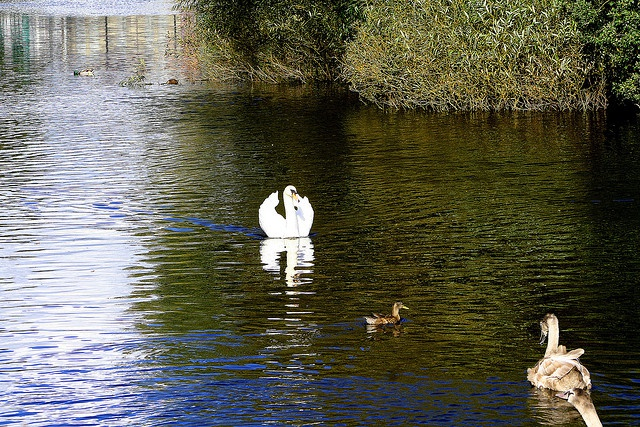Describe the objects in this image and their specific colors. I can see bird in darkgreen, ivory, tan, and black tones, bird in darkgreen, white, darkgray, black, and gray tones, bird in darkgreen, black, olive, and tan tones, bird in darkgreen, ivory, darkgray, gray, and beige tones, and bird in darkgreen, maroon, brown, and black tones in this image. 